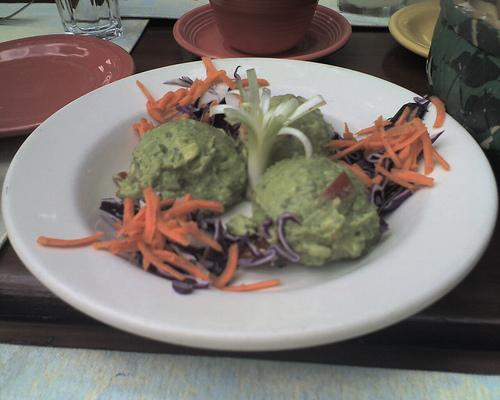What type of meal does this appear to be?

Choices:
A) meat lovers
B) vegetarian
C) chinese
D) italian vegetarian 